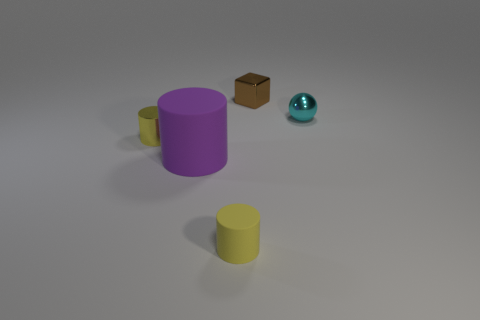Is there anything else that has the same size as the purple object?
Give a very brief answer. No. There is a cylinder that is right of the purple matte object; what size is it?
Your response must be concise. Small. There is a rubber cylinder behind the yellow rubber cylinder that is in front of the brown metal object; what size is it?
Your answer should be compact. Large. What is the material of the other cylinder that is the same size as the yellow shiny cylinder?
Provide a short and direct response. Rubber. There is a large purple cylinder; are there any tiny yellow cylinders right of it?
Your response must be concise. Yes. Are there the same number of large rubber things to the right of the brown thing and rubber cylinders?
Ensure brevity in your answer.  No. What shape is the yellow metal object that is the same size as the brown object?
Your answer should be compact. Cylinder. What is the purple cylinder made of?
Offer a terse response. Rubber. The tiny object that is both behind the small rubber cylinder and in front of the cyan thing is what color?
Make the answer very short. Yellow. Are there an equal number of small metallic cylinders that are in front of the tiny yellow metallic cylinder and tiny cubes behind the small cube?
Make the answer very short. Yes. 